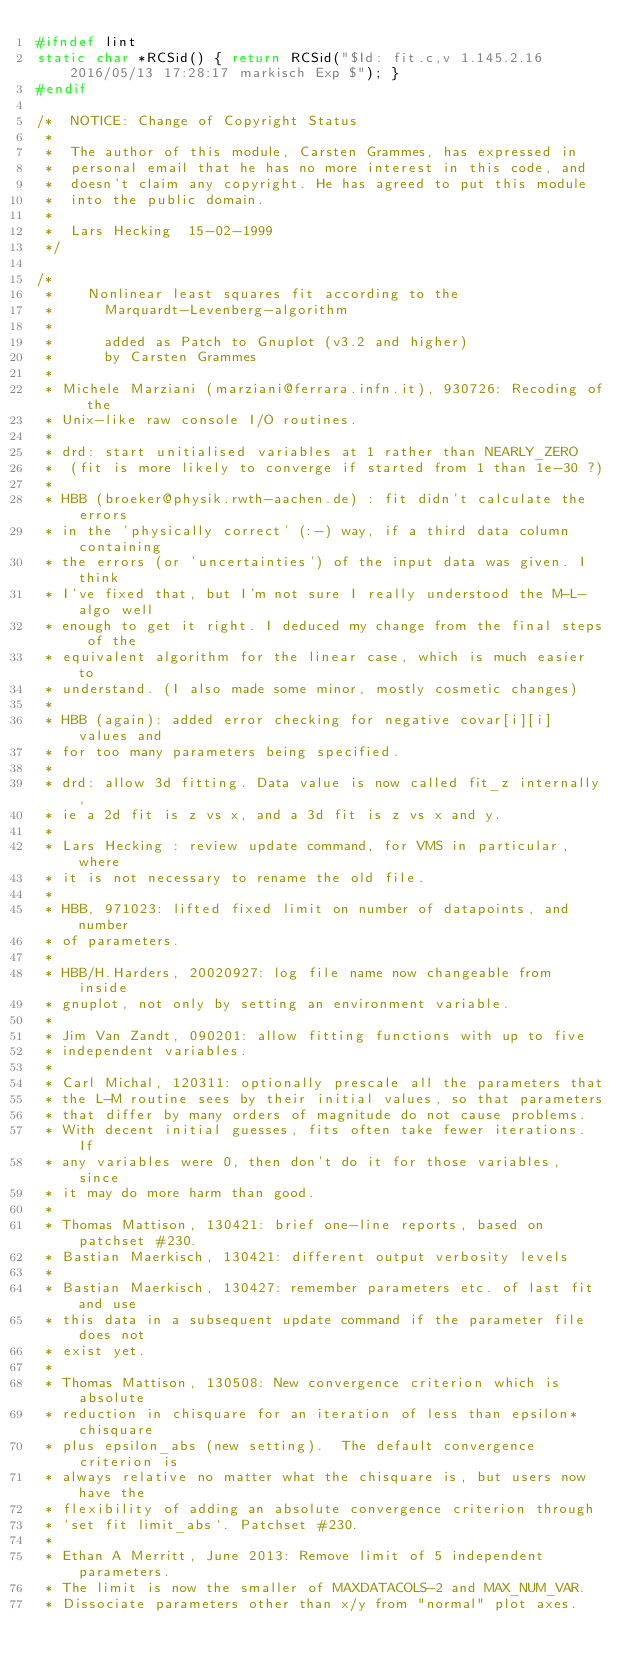Convert code to text. <code><loc_0><loc_0><loc_500><loc_500><_C_>#ifndef lint
static char *RCSid() { return RCSid("$Id: fit.c,v 1.145.2.16 2016/05/13 17:28:17 markisch Exp $"); }
#endif

/*  NOTICE: Change of Copyright Status
 *
 *  The author of this module, Carsten Grammes, has expressed in
 *  personal email that he has no more interest in this code, and
 *  doesn't claim any copyright. He has agreed to put this module
 *  into the public domain.
 *
 *  Lars Hecking  15-02-1999
 */

/*
 *    Nonlinear least squares fit according to the
 *      Marquardt-Levenberg-algorithm
 *
 *      added as Patch to Gnuplot (v3.2 and higher)
 *      by Carsten Grammes
 *
 * Michele Marziani (marziani@ferrara.infn.it), 930726: Recoding of the
 * Unix-like raw console I/O routines.
 *
 * drd: start unitialised variables at 1 rather than NEARLY_ZERO
 *  (fit is more likely to converge if started from 1 than 1e-30 ?)
 *
 * HBB (broeker@physik.rwth-aachen.de) : fit didn't calculate the errors
 * in the 'physically correct' (:-) way, if a third data column containing
 * the errors (or 'uncertainties') of the input data was given. I think
 * I've fixed that, but I'm not sure I really understood the M-L-algo well
 * enough to get it right. I deduced my change from the final steps of the
 * equivalent algorithm for the linear case, which is much easier to
 * understand. (I also made some minor, mostly cosmetic changes)
 *
 * HBB (again): added error checking for negative covar[i][i] values and
 * for too many parameters being specified.
 *
 * drd: allow 3d fitting. Data value is now called fit_z internally,
 * ie a 2d fit is z vs x, and a 3d fit is z vs x and y.
 *
 * Lars Hecking : review update command, for VMS in particular, where
 * it is not necessary to rename the old file.
 *
 * HBB, 971023: lifted fixed limit on number of datapoints, and number
 * of parameters.
 *
 * HBB/H.Harders, 20020927: log file name now changeable from inside
 * gnuplot, not only by setting an environment variable.
 *
 * Jim Van Zandt, 090201: allow fitting functions with up to five
 * independent variables.
 *
 * Carl Michal, 120311: optionally prescale all the parameters that
 * the L-M routine sees by their initial values, so that parameters
 * that differ by many orders of magnitude do not cause problems.
 * With decent initial guesses, fits often take fewer iterations. If
 * any variables were 0, then don't do it for those variables, since
 * it may do more harm than good.
 *
 * Thomas Mattison, 130421: brief one-line reports, based on patchset #230.
 * Bastian Maerkisch, 130421: different output verbosity levels
 *
 * Bastian Maerkisch, 130427: remember parameters etc. of last fit and use
 * this data in a subsequent update command if the parameter file does not
 * exist yet.
 *
 * Thomas Mattison, 130508: New convergence criterion which is absolute
 * reduction in chisquare for an iteration of less than epsilon*chisquare
 * plus epsilon_abs (new setting).  The default convergence criterion is
 * always relative no matter what the chisquare is, but users now have the
 * flexibility of adding an absolute convergence criterion through
 * `set fit limit_abs`. Patchset #230.
 *
 * Ethan A Merritt, June 2013: Remove limit of 5 independent parameters.
 * The limit is now the smaller of MAXDATACOLS-2 and MAX_NUM_VAR.
 * Dissociate parameters other than x/y from "normal" plot axes.</code> 